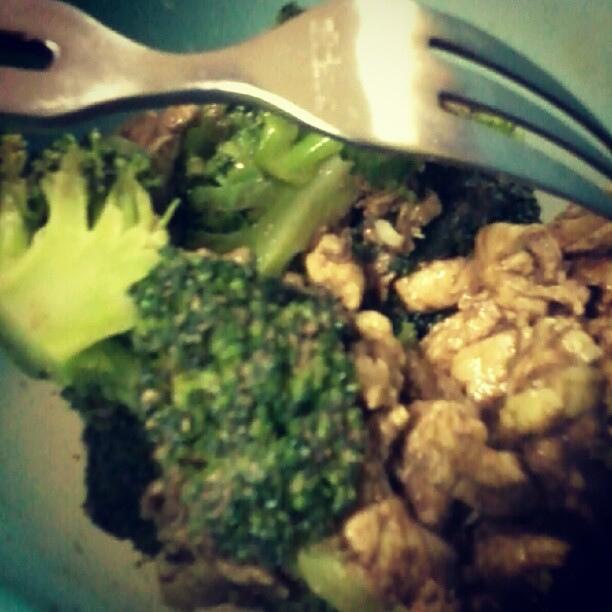What color is the utensil?
Short answer required. Silver. What is utensil present?
Concise answer only. Fork. What green vegetable is on the plate?
Short answer required. Broccoli. 